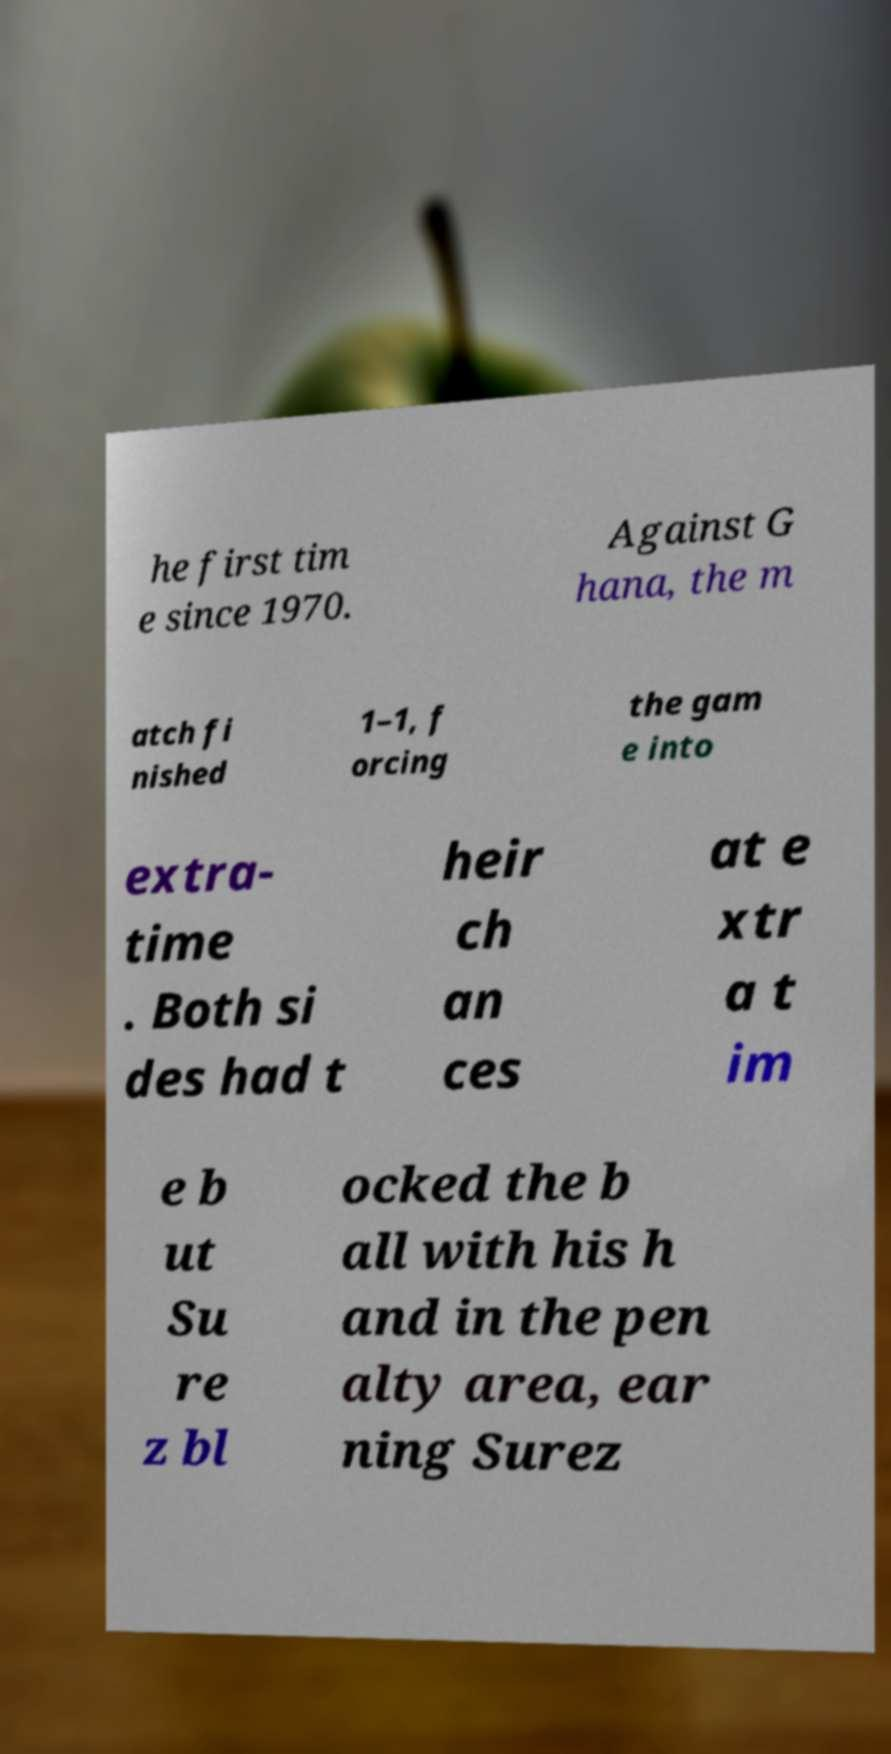There's text embedded in this image that I need extracted. Can you transcribe it verbatim? he first tim e since 1970. Against G hana, the m atch fi nished 1–1, f orcing the gam e into extra- time . Both si des had t heir ch an ces at e xtr a t im e b ut Su re z bl ocked the b all with his h and in the pen alty area, ear ning Surez 